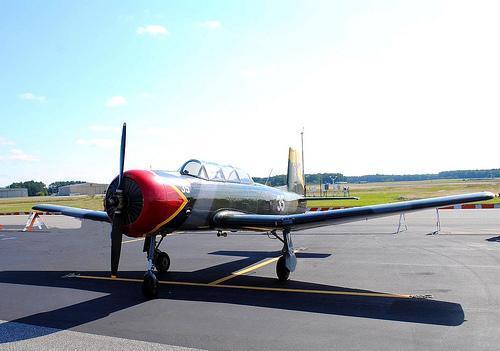How many striped barriers are visible?
Give a very brief answer. 3. How many planes are there?
Give a very brief answer. 1. 